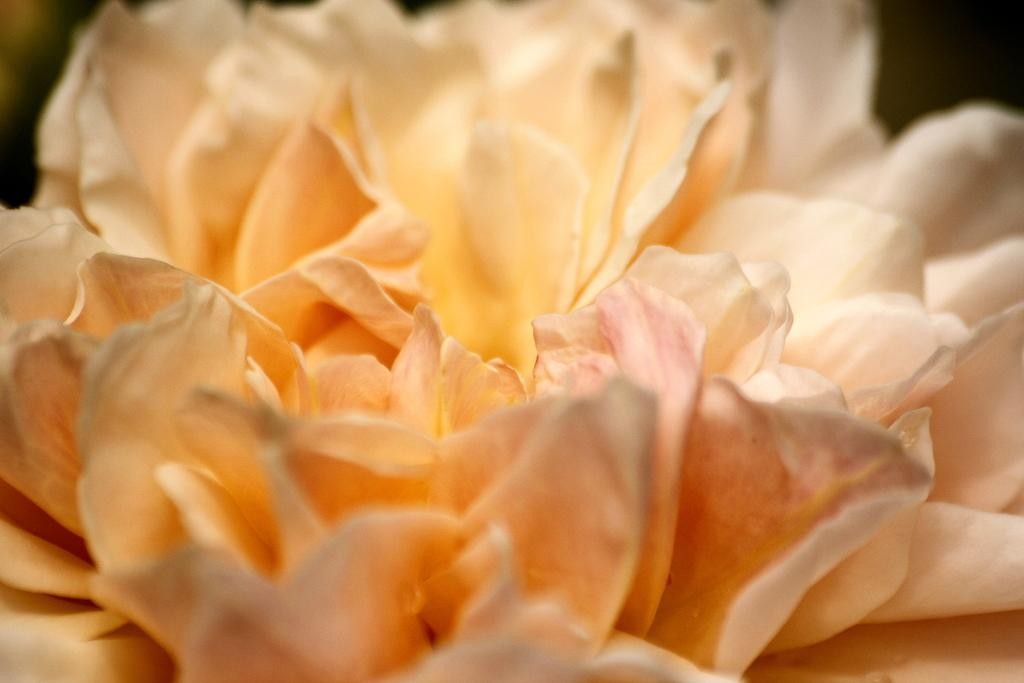What is the main subject of the image? There is a close view of a flower in the image. How is the background of the image depicted? The background of the image is blurred and dark. How many snakes are slithering around the flower in the image? There are no snakes present in the image; it features a close view of a flower with a blurred and dark background. What is the girl doing in the image? There is no girl present in the image; it features a close view of a flower with a blurred and dark background. 